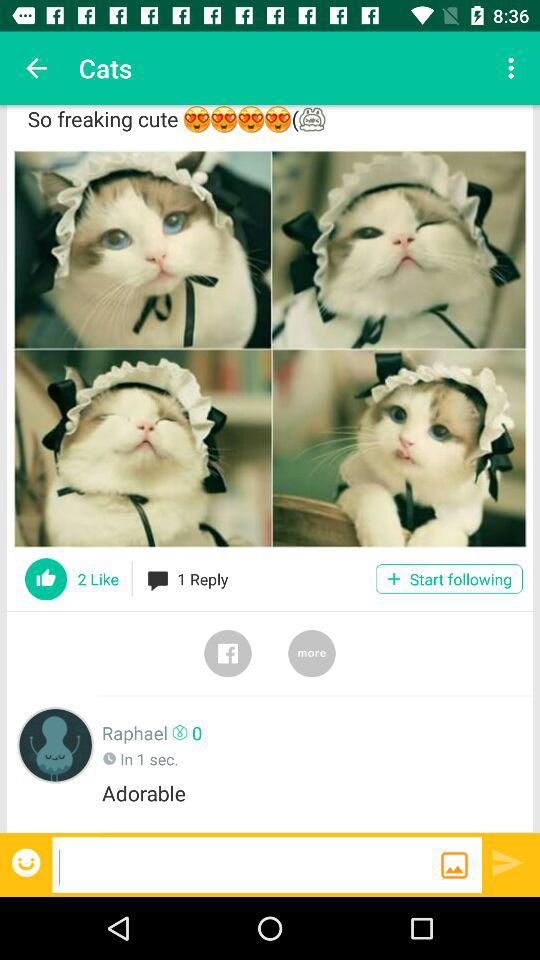How many likes does the post have?
Answer the question using a single word or phrase. 2 